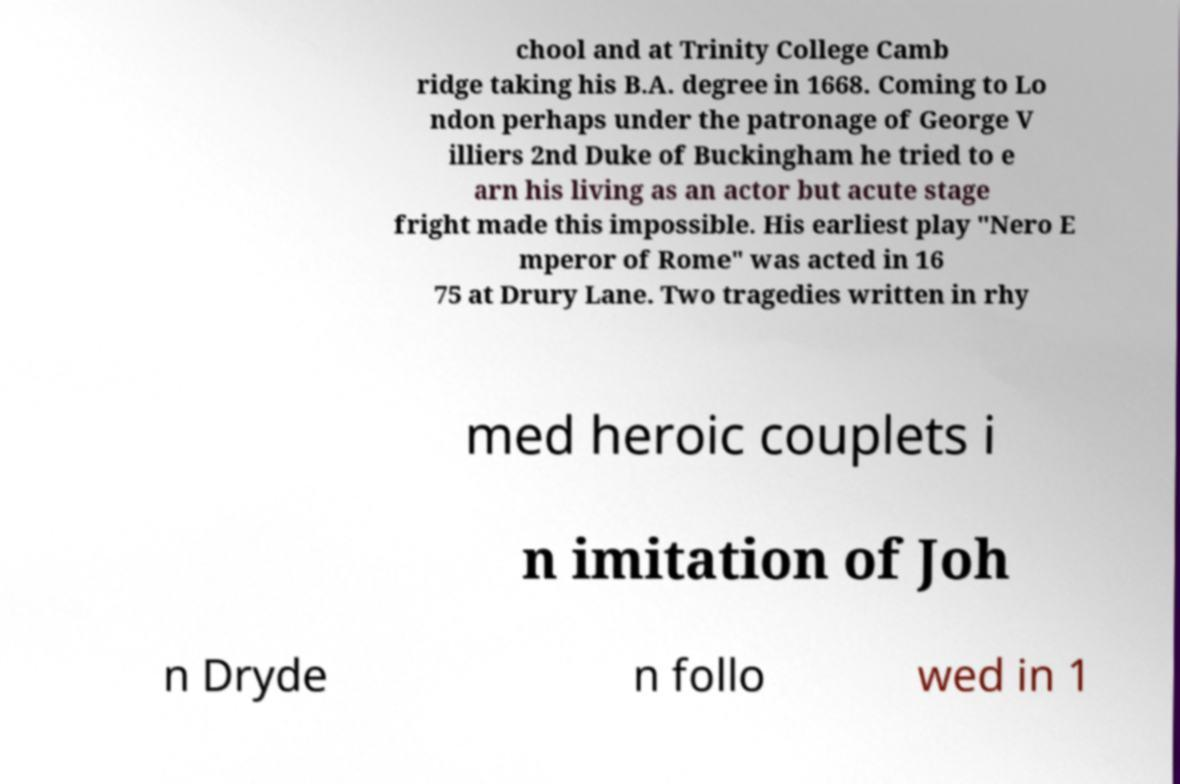Please identify and transcribe the text found in this image. chool and at Trinity College Camb ridge taking his B.A. degree in 1668. Coming to Lo ndon perhaps under the patronage of George V illiers 2nd Duke of Buckingham he tried to e arn his living as an actor but acute stage fright made this impossible. His earliest play "Nero E mperor of Rome" was acted in 16 75 at Drury Lane. Two tragedies written in rhy med heroic couplets i n imitation of Joh n Dryde n follo wed in 1 